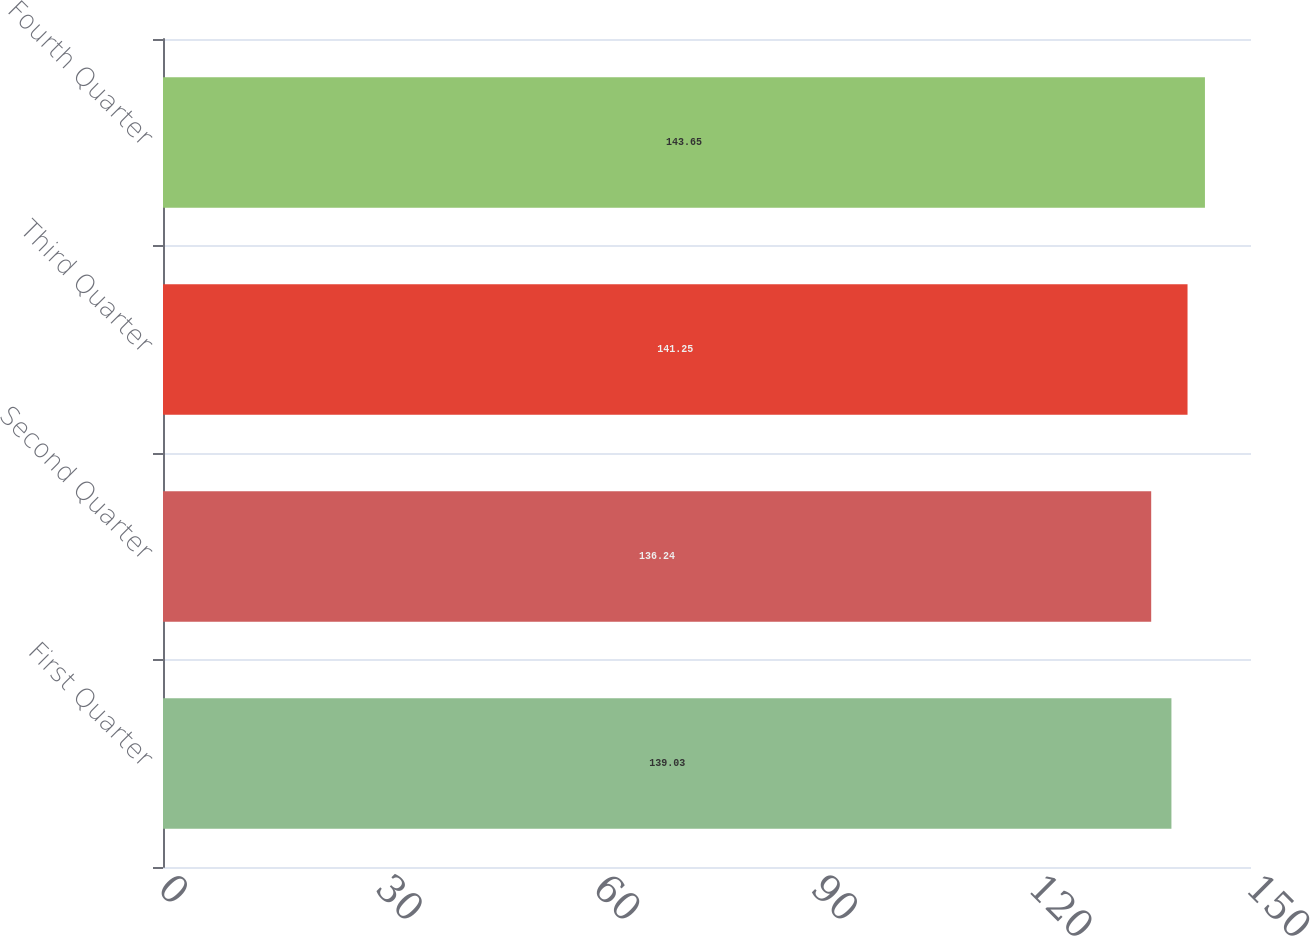Convert chart. <chart><loc_0><loc_0><loc_500><loc_500><bar_chart><fcel>First Quarter<fcel>Second Quarter<fcel>Third Quarter<fcel>Fourth Quarter<nl><fcel>139.03<fcel>136.24<fcel>141.25<fcel>143.65<nl></chart> 